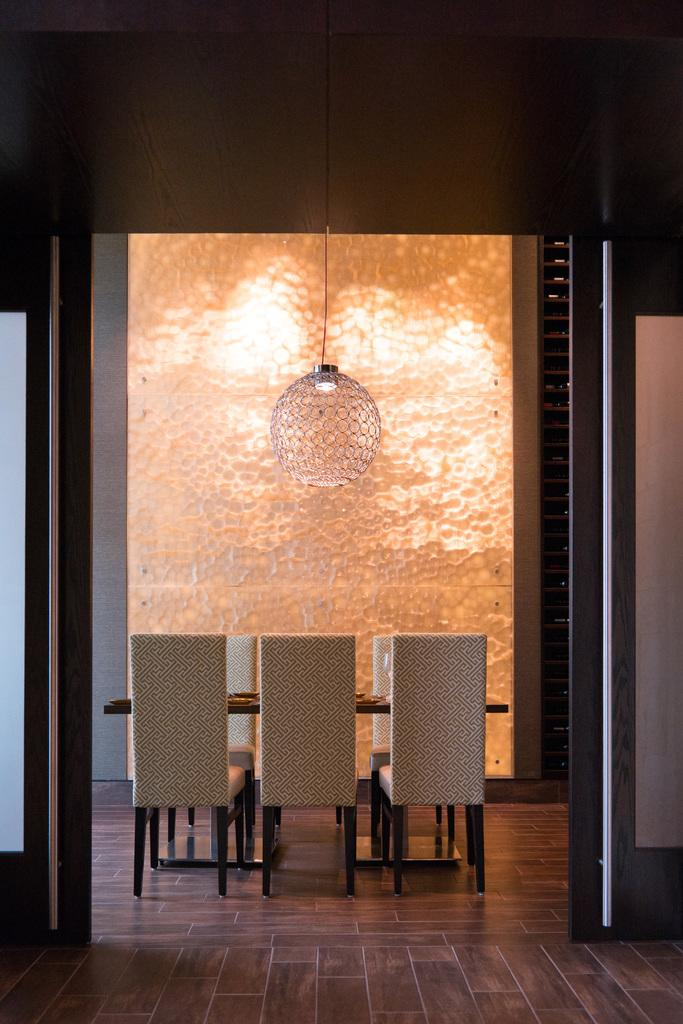What type of furniture is present in the image? There are chairs and a table in the image. What is used for illumination in the image? There is a light in the image. What is the color of the floor in the image? The floor is brown in color. What colors are present in the background of the image? The background of the image is orange and white. What type of activity is taking place in the image during the night? The image does not depict any activity, nor does it indicate a specific time of day such as night. 